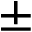Convert formula to latex. <formula><loc_0><loc_0><loc_500><loc_500>\pm</formula> 